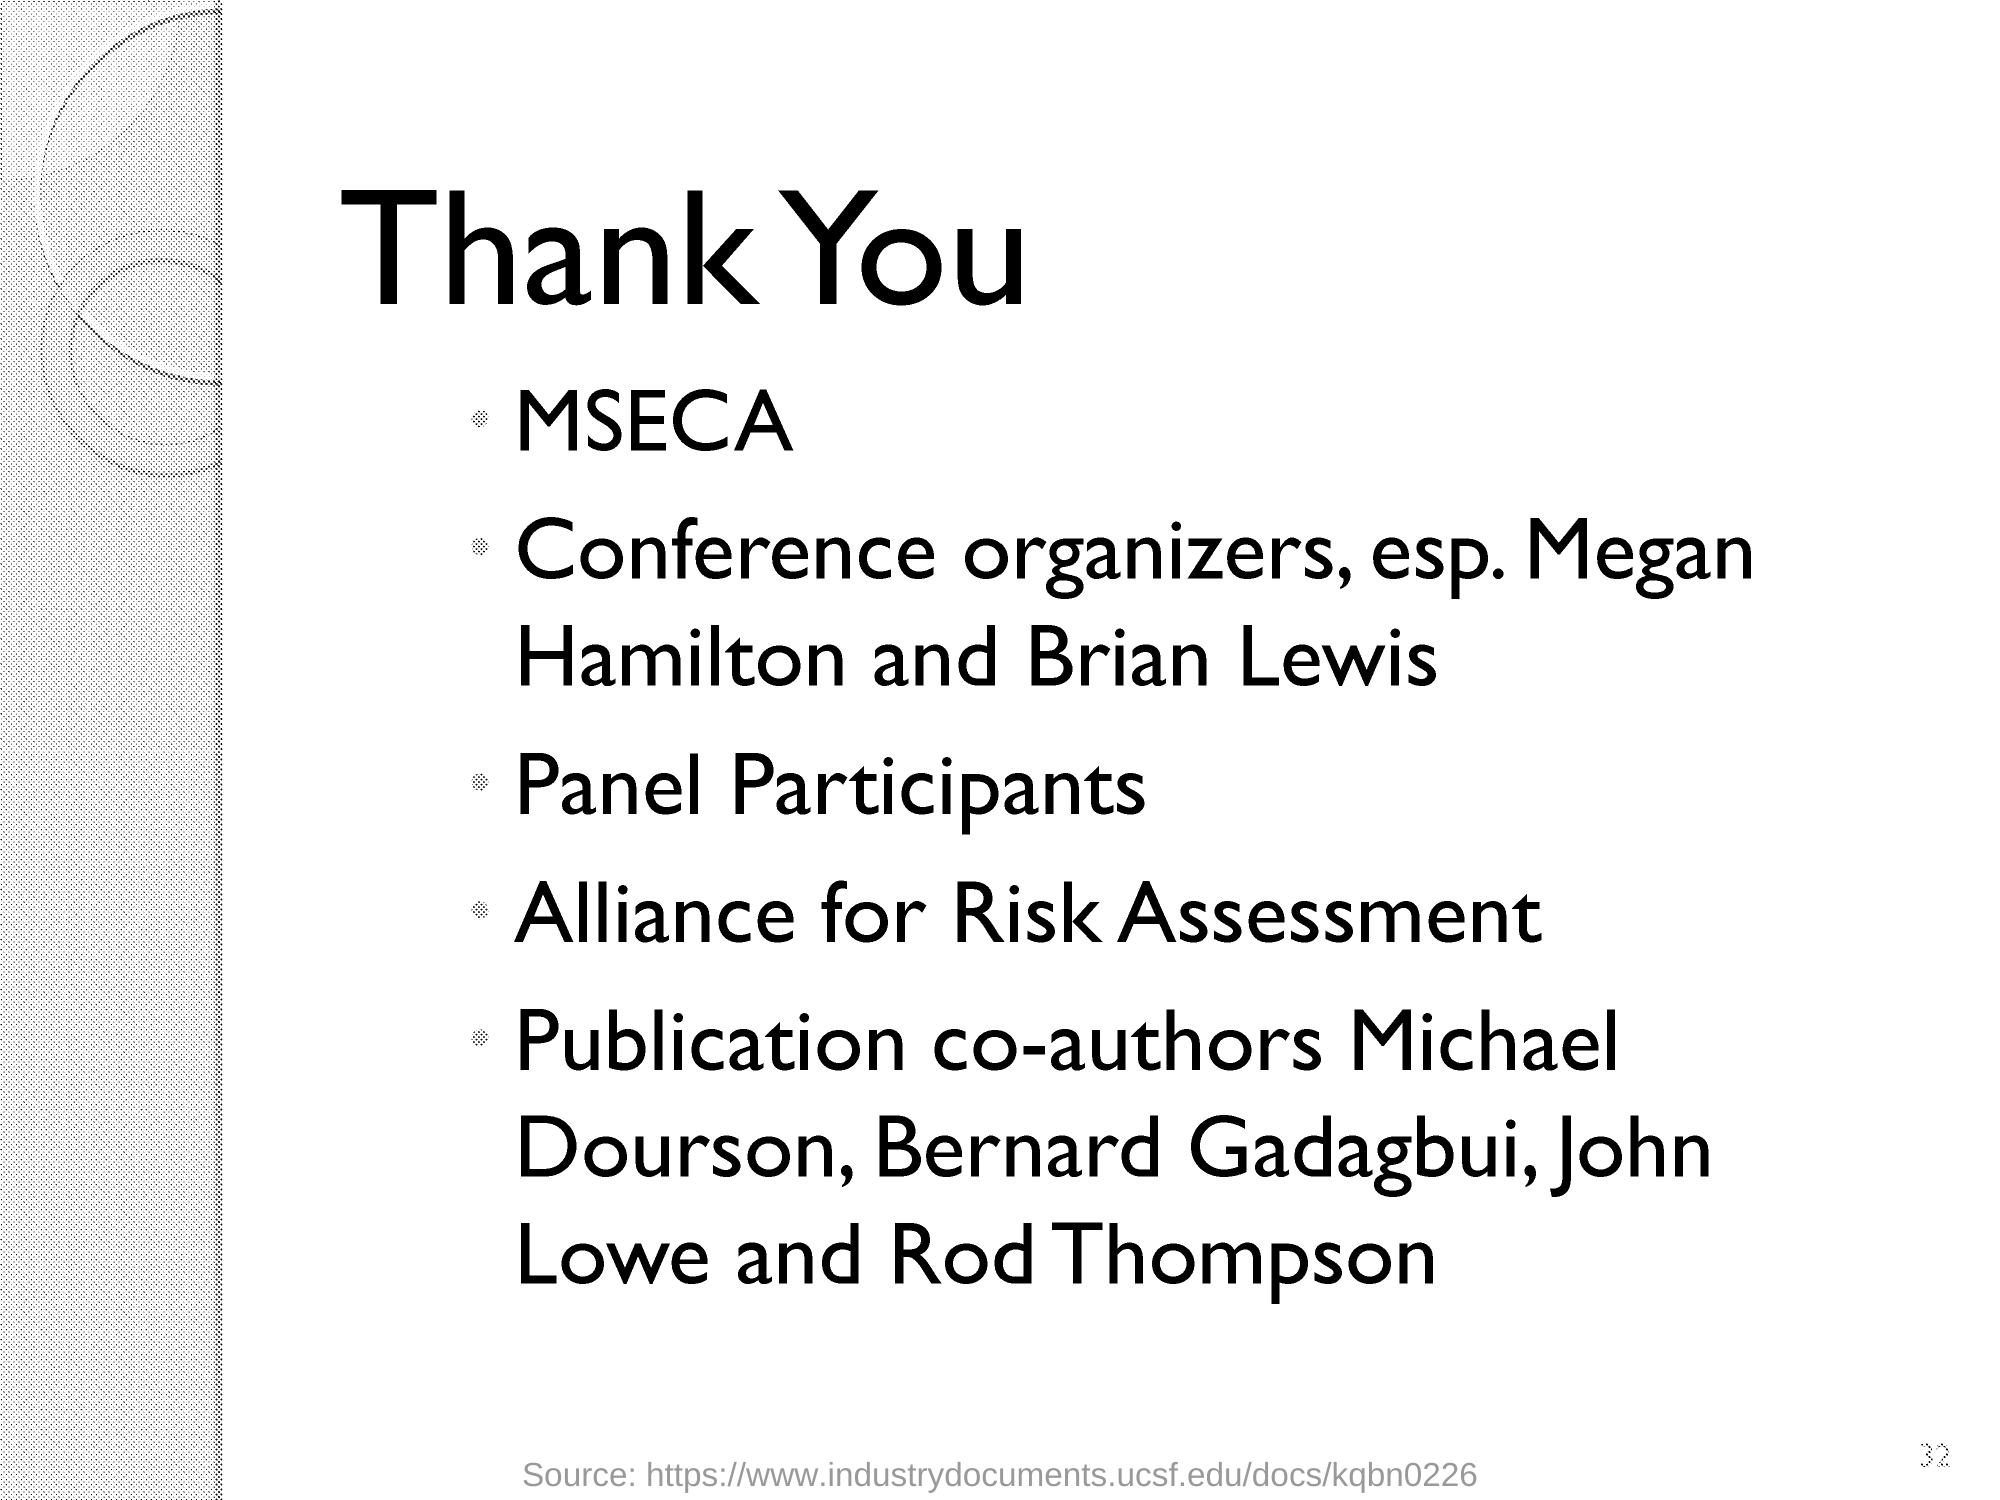Outline some significant characteristics in this image. The publication co-authors are Michael Dourson, Bernard Gadagbui, John Lowe, and Rod Thompson. The heading of the document is as follows: "Thank You. 